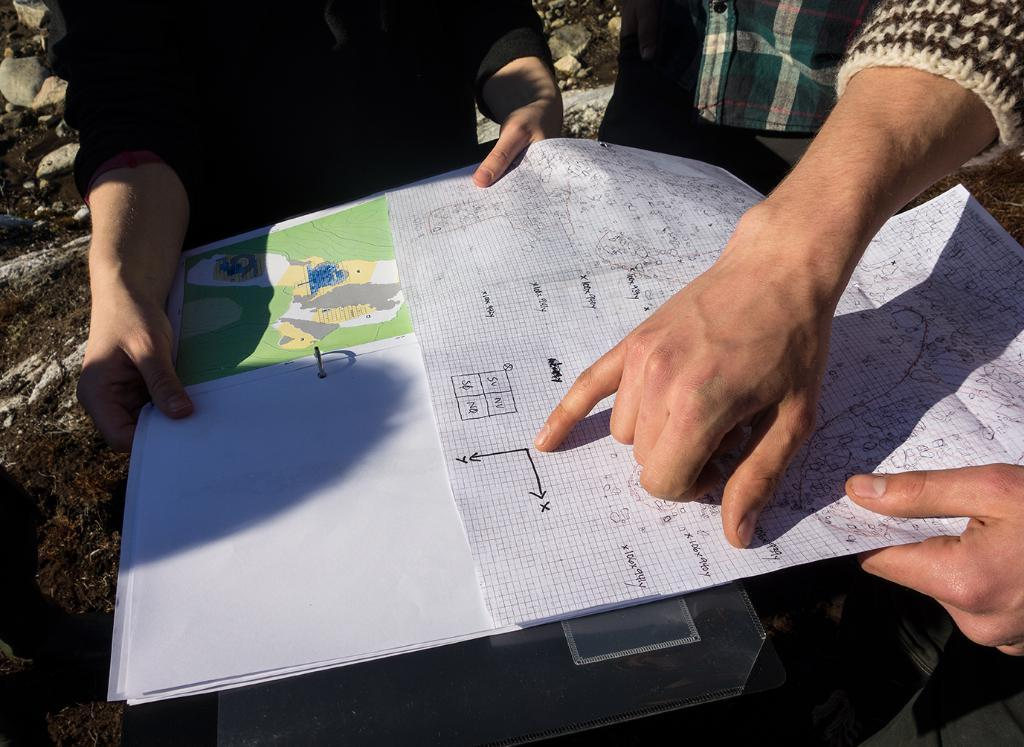Who or what is present in the image? There are people in the image. What are the people holding in the image? The people are holding charts in the image. Can you describe the object in the image? There is an object in the image, but its description is not provided in the facts. What can be seen on the left side of the image? There are stones and grass on the left side of the image. How many tests can be seen being taken in the image? There is no indication of any tests being taken in the image; it features people holding charts. What type of swing is visible in the image? There is no swing present in the image. 